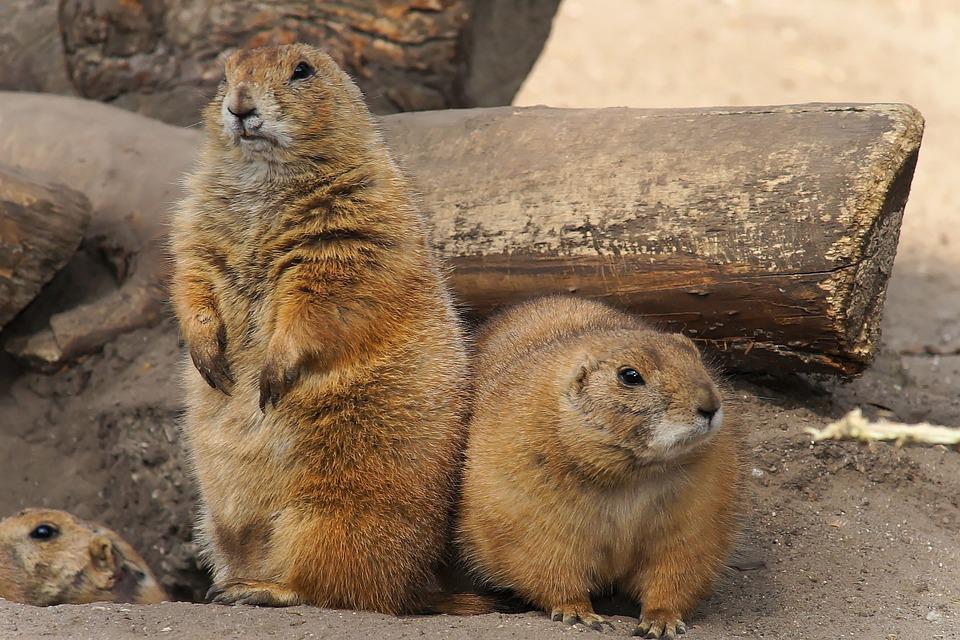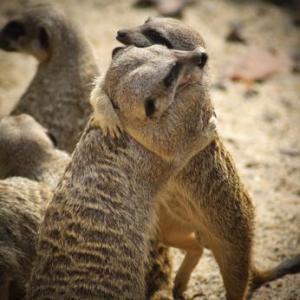The first image is the image on the left, the second image is the image on the right. Evaluate the accuracy of this statement regarding the images: "there are no less then 3 animals in the right pic". Is it true? Answer yes or no. Yes. 